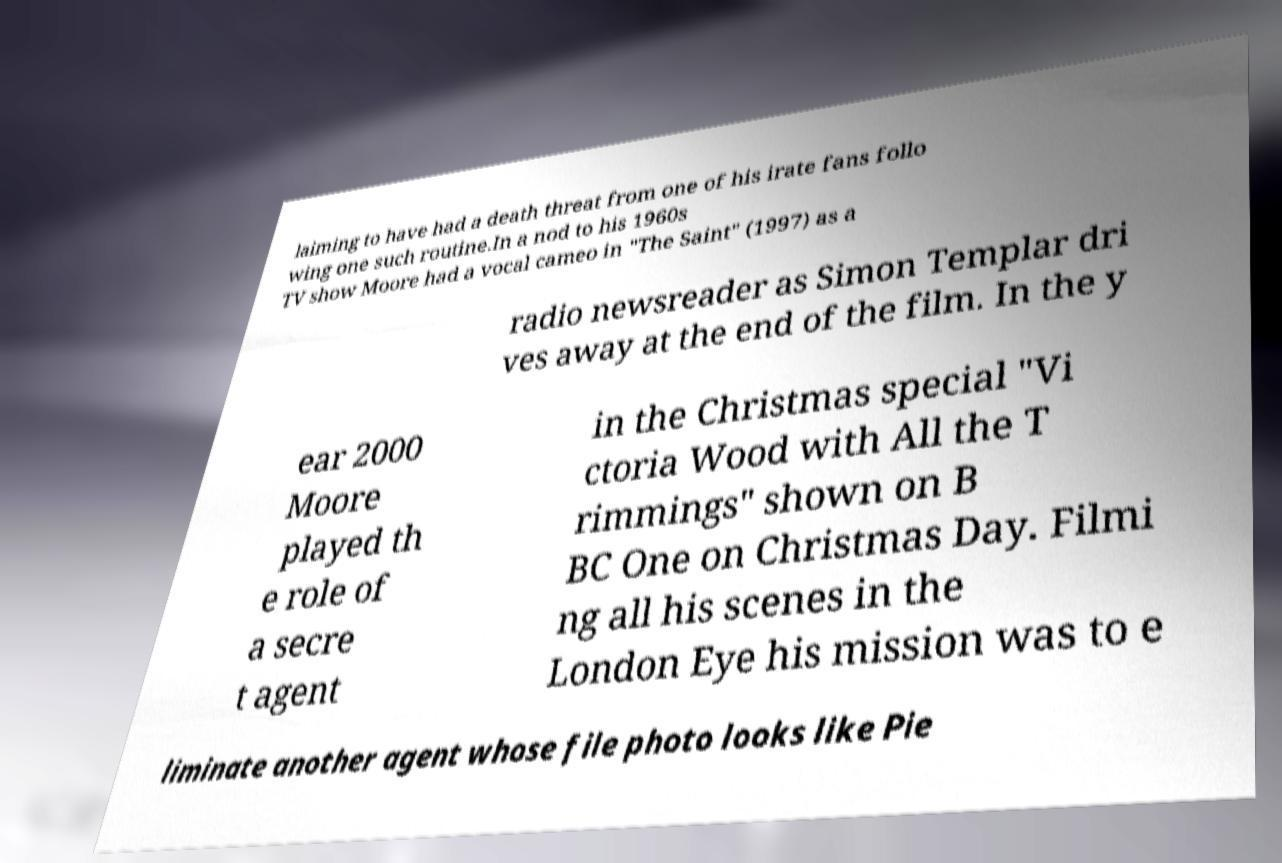What messages or text are displayed in this image? I need them in a readable, typed format. laiming to have had a death threat from one of his irate fans follo wing one such routine.In a nod to his 1960s TV show Moore had a vocal cameo in "The Saint" (1997) as a radio newsreader as Simon Templar dri ves away at the end of the film. In the y ear 2000 Moore played th e role of a secre t agent in the Christmas special "Vi ctoria Wood with All the T rimmings" shown on B BC One on Christmas Day. Filmi ng all his scenes in the London Eye his mission was to e liminate another agent whose file photo looks like Pie 